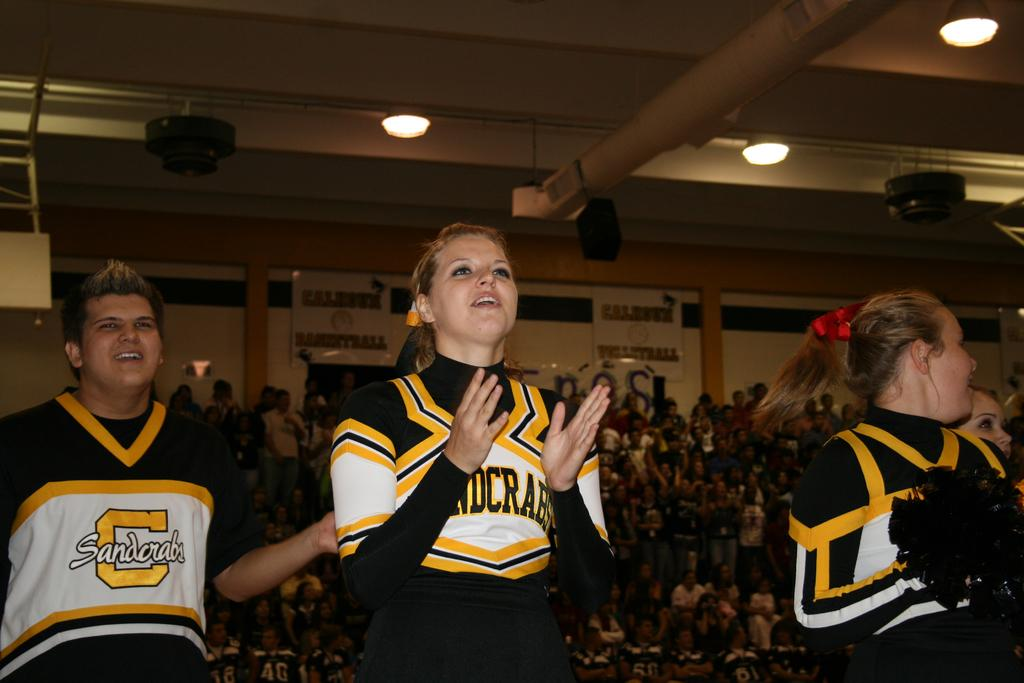How many people are in the image? There are three persons in the image. What can be seen in the background of the image? In the background of the image, there are lights, boards, a wall, and a crowd. Can you describe the lighting in the image? The lights in the background of the image provide illumination. What type of structure is visible in the background? There is a wall visible in the background of the image. How does the crowd in the image sort the items? There is no indication in the image that the crowd is sorting any items. What type of whip is being used by the persons in the image? There is no whip present in the image; the three persons are not using any whips. 